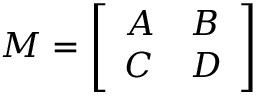Convert formula to latex. <formula><loc_0><loc_0><loc_500><loc_500>M = { \left [ \begin{array} { l l } { A } & { B } \\ { C } & { D } \end{array} \right ] }</formula> 